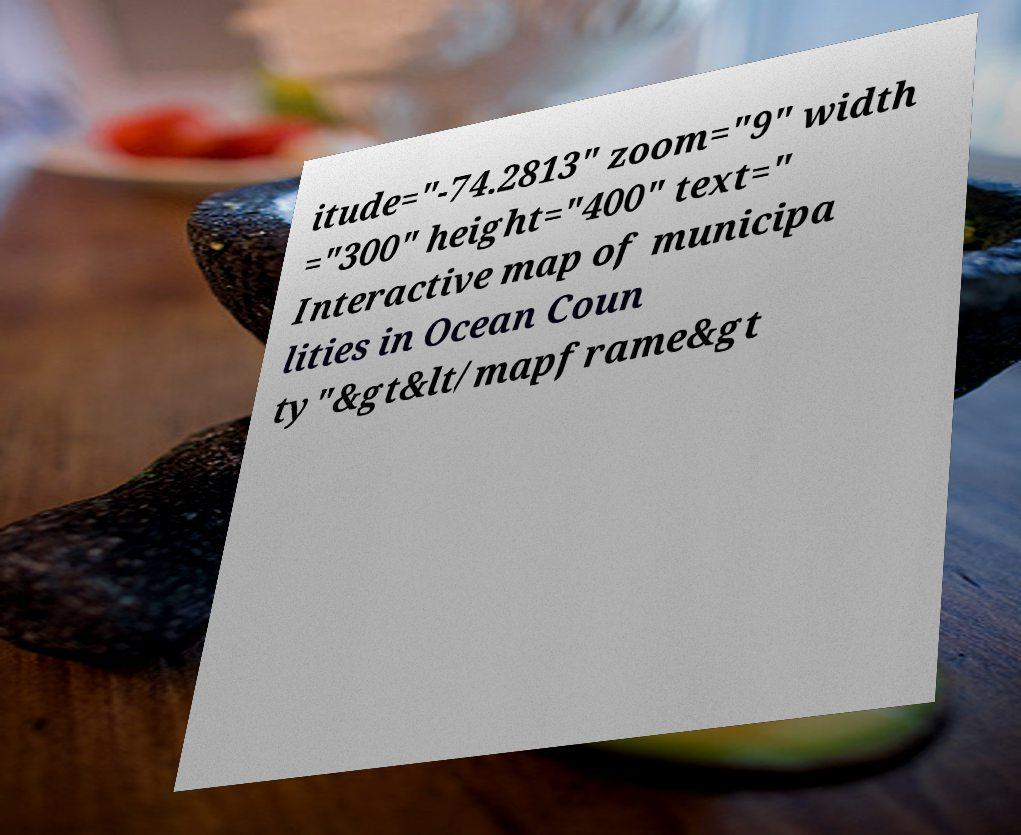Please read and relay the text visible in this image. What does it say? itude="-74.2813" zoom="9" width ="300" height="400" text=" Interactive map of municipa lities in Ocean Coun ty"&gt&lt/mapframe&gt 